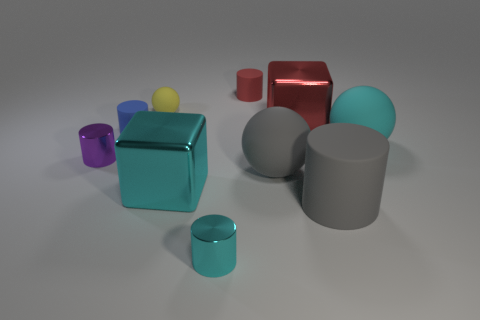How many tiny objects are the same color as the small sphere?
Your answer should be compact. 0. The red rubber thing that is the same size as the yellow sphere is what shape?
Provide a succinct answer. Cylinder. There is a cyan cylinder; are there any big cyan metal cubes in front of it?
Offer a terse response. No. Is the size of the yellow sphere the same as the gray rubber ball?
Your answer should be compact. No. What is the shape of the large metal object left of the red rubber cylinder?
Ensure brevity in your answer.  Cube. Is there a metallic cylinder of the same size as the cyan rubber object?
Your response must be concise. No. What material is the blue object that is the same size as the yellow object?
Make the answer very short. Rubber. How big is the block to the left of the small cyan metal object?
Ensure brevity in your answer.  Large. What size is the blue thing?
Provide a succinct answer. Small. Is the size of the blue rubber cylinder the same as the cyan rubber ball right of the purple metal cylinder?
Offer a very short reply. No. 